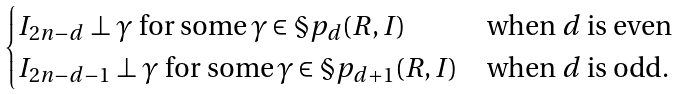<formula> <loc_0><loc_0><loc_500><loc_500>\begin{cases} I _ { 2 n - d } \perp \gamma \text { for some} \, \gamma \in \S p _ { d } ( R , I ) \, & \text {when $d$ is even} \\ I _ { 2 n - d - 1 } \perp \gamma \text { for some} \, \gamma \in \S p _ { d + 1 } ( R , I ) \, & \text {when $d$ is odd} . \end{cases}</formula> 